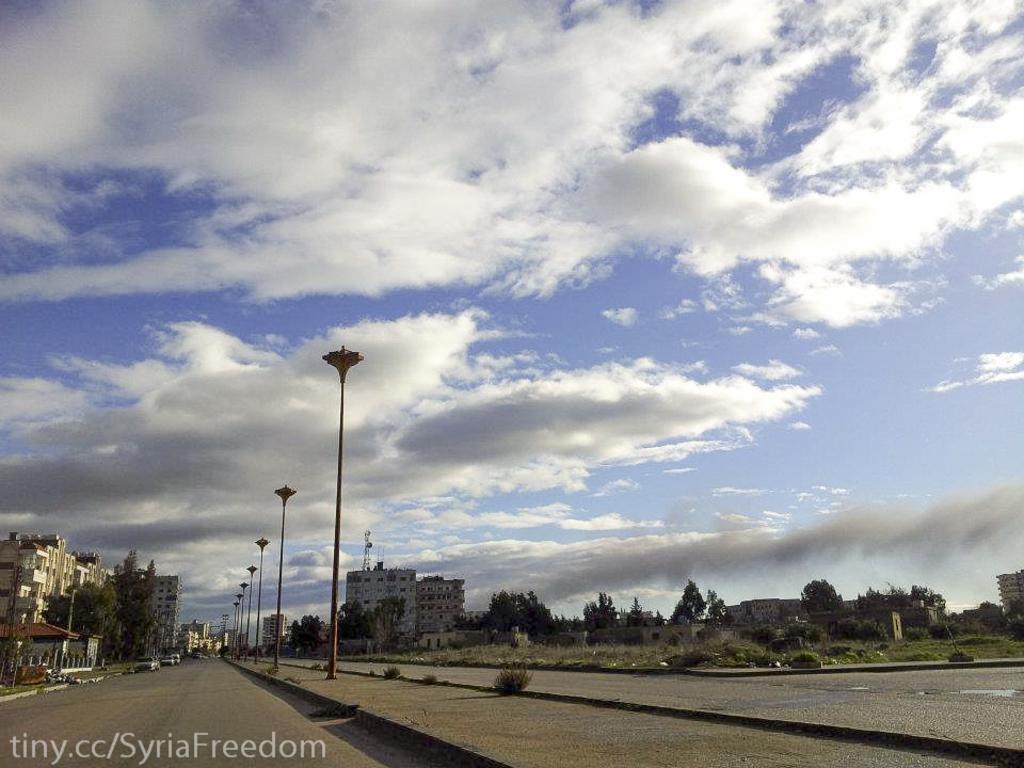In one or two sentences, can you explain what this image depicts? The picture is taken outside a city. In the foreground of the picture it is road and divider. On the left side there are buildings and trees. In the center of the picture there are street lights, trees and buildings. On the left there are trees, shrubs, buildings and road. It is a sunny day, sky is little bit cloudy. 